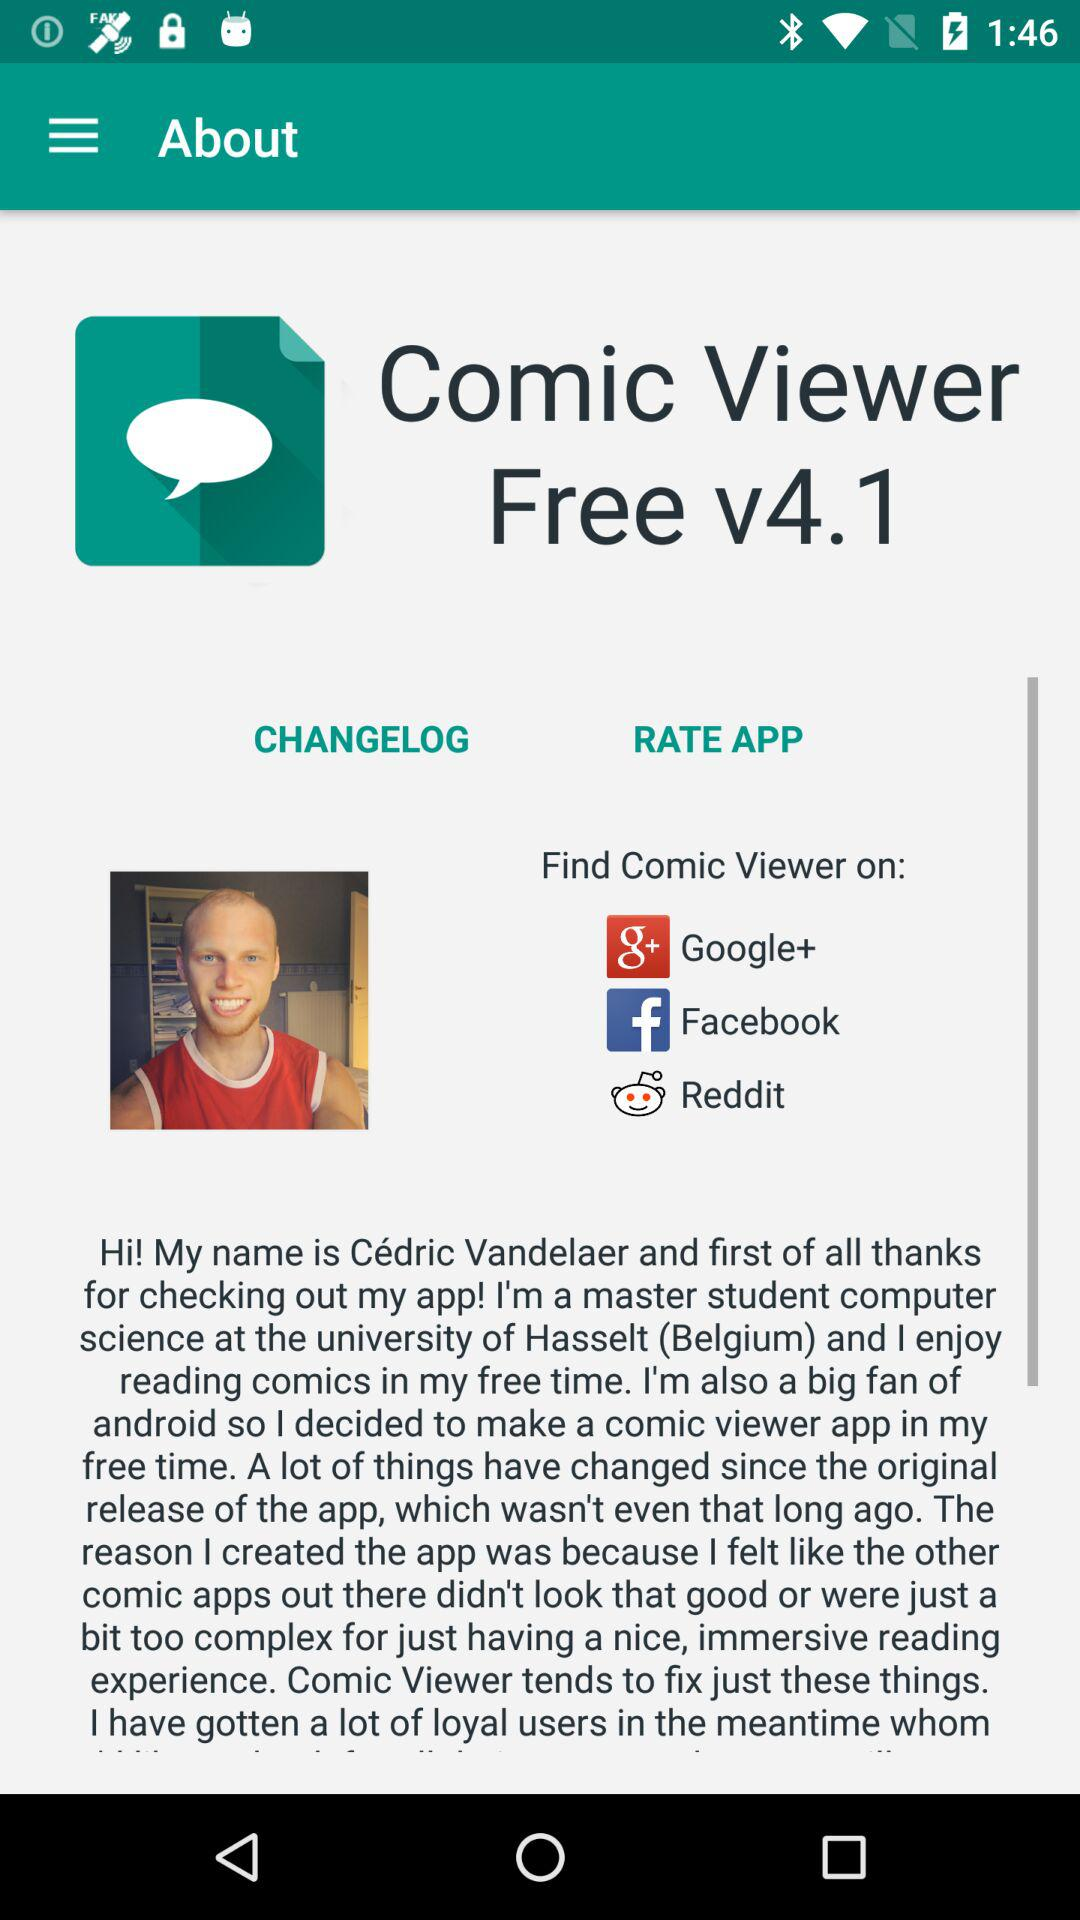What features does the Comic Viewer app offer to enhance user experience? The Comic Viewer app offers a simplified user interface that focuses on providing an immersive reading experience for comic enthusiasts. It avoids overly complex features, focusing instead on the essentials of comic viewing. This approach makes it appealing to users seeking a straightforward, user-friendly app. 